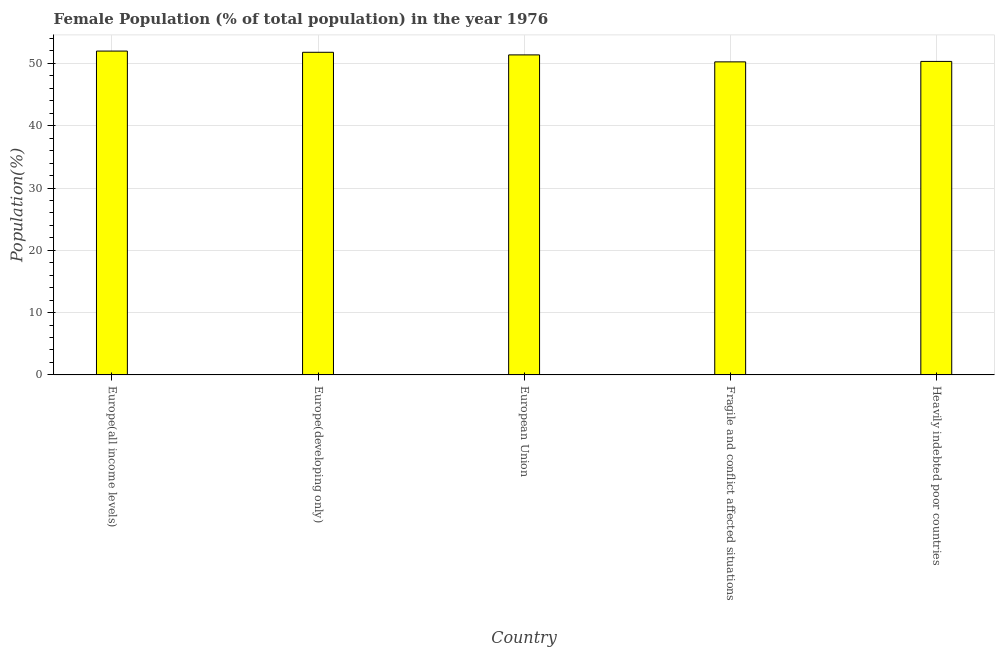Does the graph contain any zero values?
Offer a terse response. No. Does the graph contain grids?
Make the answer very short. Yes. What is the title of the graph?
Your answer should be very brief. Female Population (% of total population) in the year 1976. What is the label or title of the X-axis?
Provide a succinct answer. Country. What is the label or title of the Y-axis?
Your response must be concise. Population(%). What is the female population in Europe(developing only)?
Keep it short and to the point. 51.79. Across all countries, what is the maximum female population?
Your answer should be very brief. 51.99. Across all countries, what is the minimum female population?
Offer a very short reply. 50.25. In which country was the female population maximum?
Keep it short and to the point. Europe(all income levels). In which country was the female population minimum?
Your answer should be compact. Fragile and conflict affected situations. What is the sum of the female population?
Offer a very short reply. 255.73. What is the difference between the female population in Fragile and conflict affected situations and Heavily indebted poor countries?
Provide a short and direct response. -0.07. What is the average female population per country?
Provide a short and direct response. 51.15. What is the median female population?
Make the answer very short. 51.37. What is the ratio of the female population in Europe(all income levels) to that in Europe(developing only)?
Provide a short and direct response. 1. Is the female population in Europe(all income levels) less than that in Fragile and conflict affected situations?
Make the answer very short. No. What is the difference between the highest and the second highest female population?
Provide a succinct answer. 0.2. Is the sum of the female population in Europe(all income levels) and Europe(developing only) greater than the maximum female population across all countries?
Make the answer very short. Yes. What is the difference between the highest and the lowest female population?
Give a very brief answer. 1.73. Are all the bars in the graph horizontal?
Offer a very short reply. No. How many countries are there in the graph?
Provide a short and direct response. 5. What is the difference between two consecutive major ticks on the Y-axis?
Offer a very short reply. 10. What is the Population(%) in Europe(all income levels)?
Offer a very short reply. 51.99. What is the Population(%) of Europe(developing only)?
Your answer should be compact. 51.79. What is the Population(%) in European Union?
Keep it short and to the point. 51.37. What is the Population(%) in Fragile and conflict affected situations?
Your response must be concise. 50.25. What is the Population(%) of Heavily indebted poor countries?
Make the answer very short. 50.33. What is the difference between the Population(%) in Europe(all income levels) and Europe(developing only)?
Keep it short and to the point. 0.2. What is the difference between the Population(%) in Europe(all income levels) and European Union?
Make the answer very short. 0.61. What is the difference between the Population(%) in Europe(all income levels) and Fragile and conflict affected situations?
Your response must be concise. 1.73. What is the difference between the Population(%) in Europe(all income levels) and Heavily indebted poor countries?
Your answer should be compact. 1.66. What is the difference between the Population(%) in Europe(developing only) and European Union?
Provide a succinct answer. 0.42. What is the difference between the Population(%) in Europe(developing only) and Fragile and conflict affected situations?
Provide a succinct answer. 1.54. What is the difference between the Population(%) in Europe(developing only) and Heavily indebted poor countries?
Make the answer very short. 1.46. What is the difference between the Population(%) in European Union and Fragile and conflict affected situations?
Your answer should be very brief. 1.12. What is the difference between the Population(%) in European Union and Heavily indebted poor countries?
Your answer should be compact. 1.05. What is the difference between the Population(%) in Fragile and conflict affected situations and Heavily indebted poor countries?
Make the answer very short. -0.07. What is the ratio of the Population(%) in Europe(all income levels) to that in Europe(developing only)?
Your response must be concise. 1. What is the ratio of the Population(%) in Europe(all income levels) to that in European Union?
Your answer should be compact. 1.01. What is the ratio of the Population(%) in Europe(all income levels) to that in Fragile and conflict affected situations?
Keep it short and to the point. 1.03. What is the ratio of the Population(%) in Europe(all income levels) to that in Heavily indebted poor countries?
Your response must be concise. 1.03. What is the ratio of the Population(%) in Europe(developing only) to that in Fragile and conflict affected situations?
Provide a short and direct response. 1.03. What is the ratio of the Population(%) in Europe(developing only) to that in Heavily indebted poor countries?
Offer a terse response. 1.03. What is the ratio of the Population(%) in European Union to that in Heavily indebted poor countries?
Offer a terse response. 1.02. 